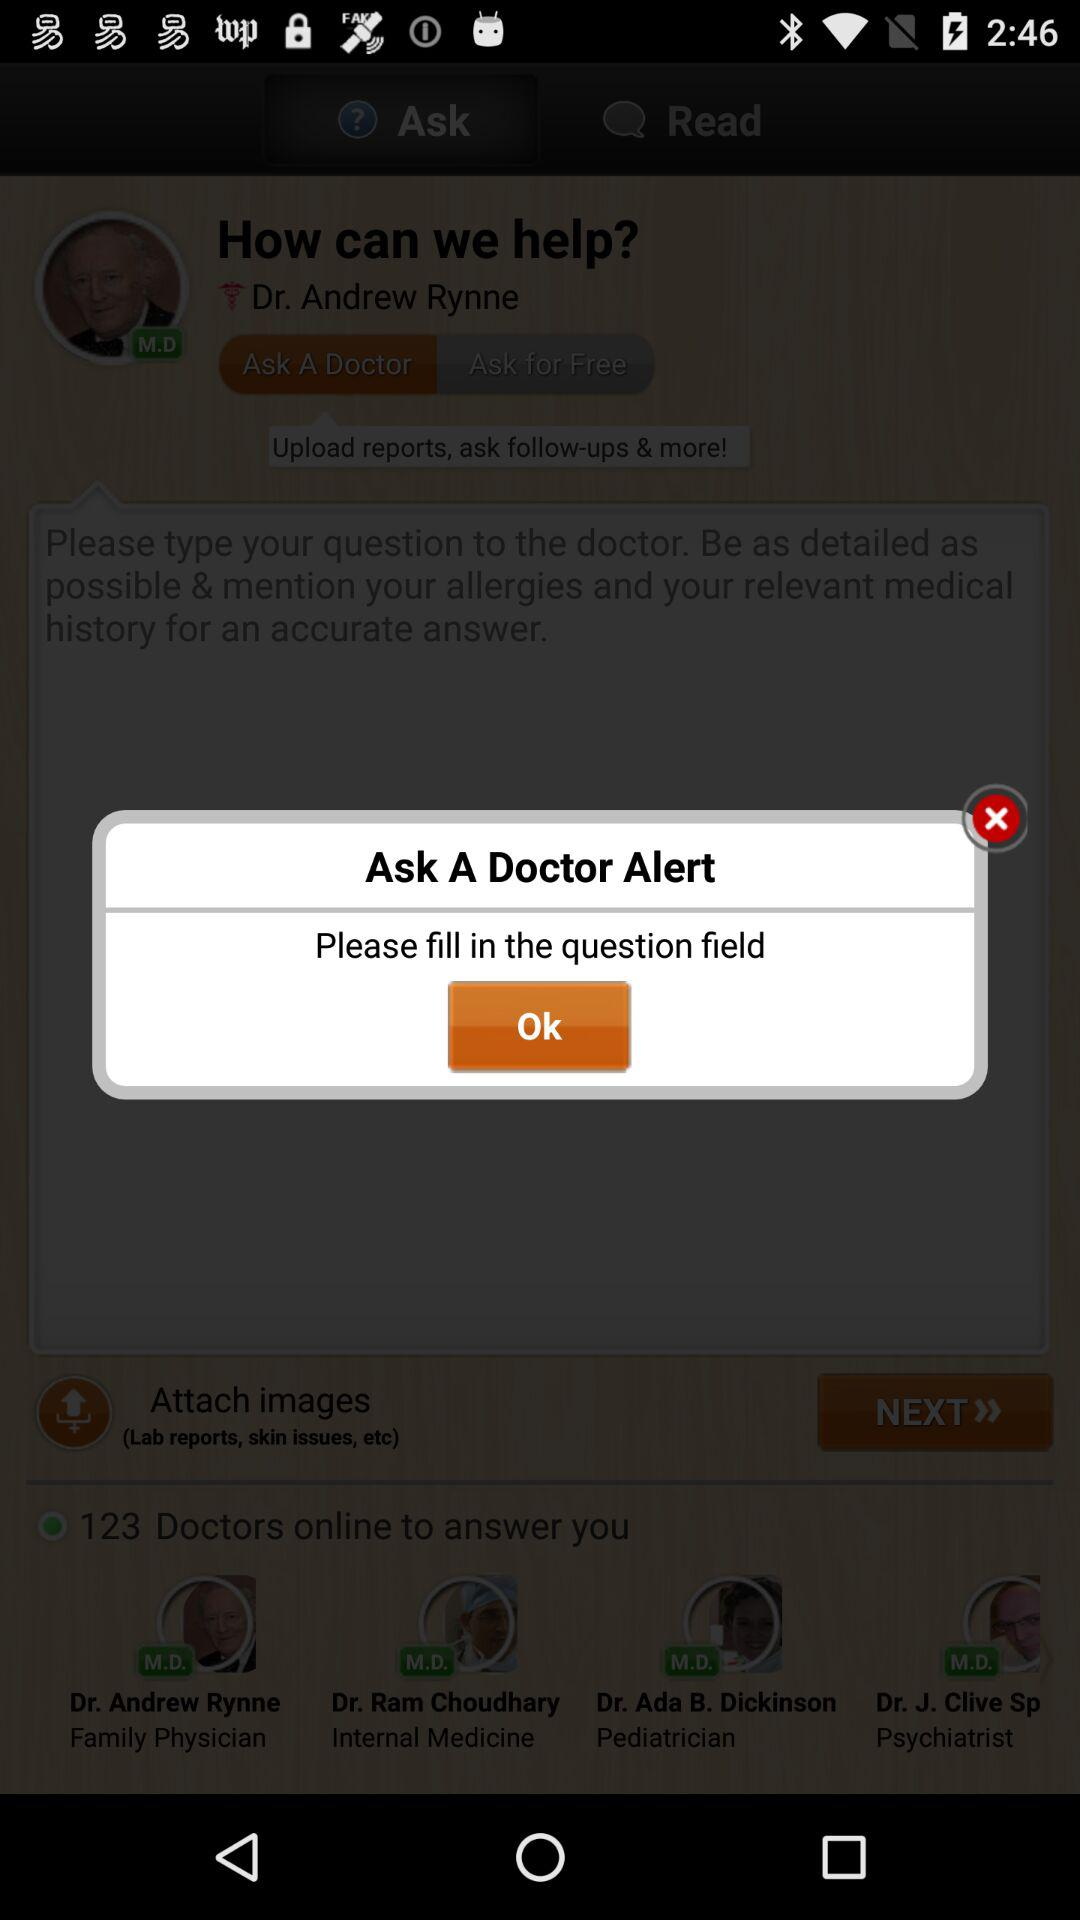What's the name of the medical degree that Doctor Andrew Rynne holds? The name of the medical degree that Doctor Andrew Rynne holds is M.D. 